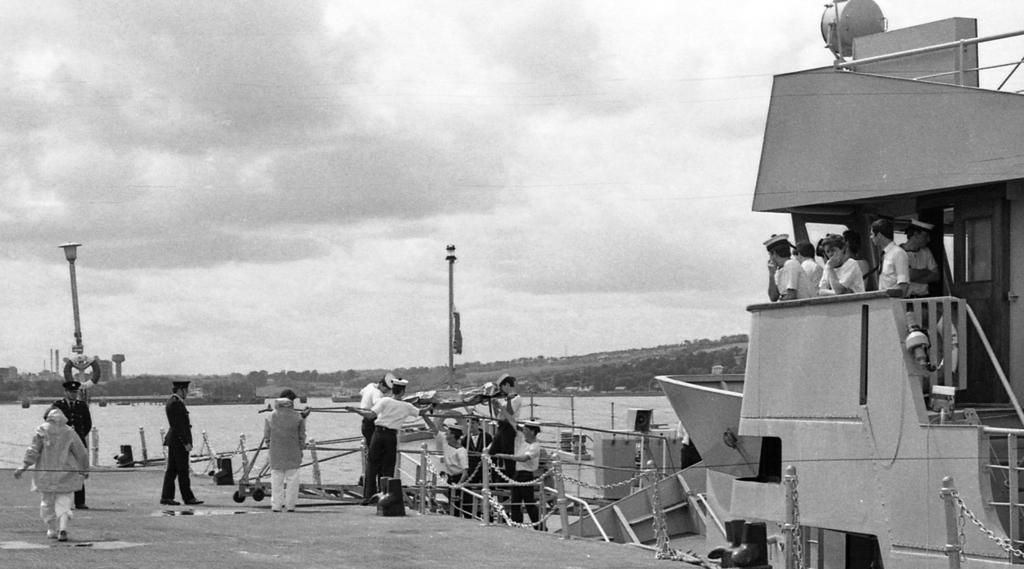Could you give a brief overview of what you see in this image? In this image there are a few people walking on the ground. There is a railing around them. Behind the railing there is the water. To the right there is a ship. In the background there are buildings and mountains. At the top there is the sky. There are street light poles on the ground. 